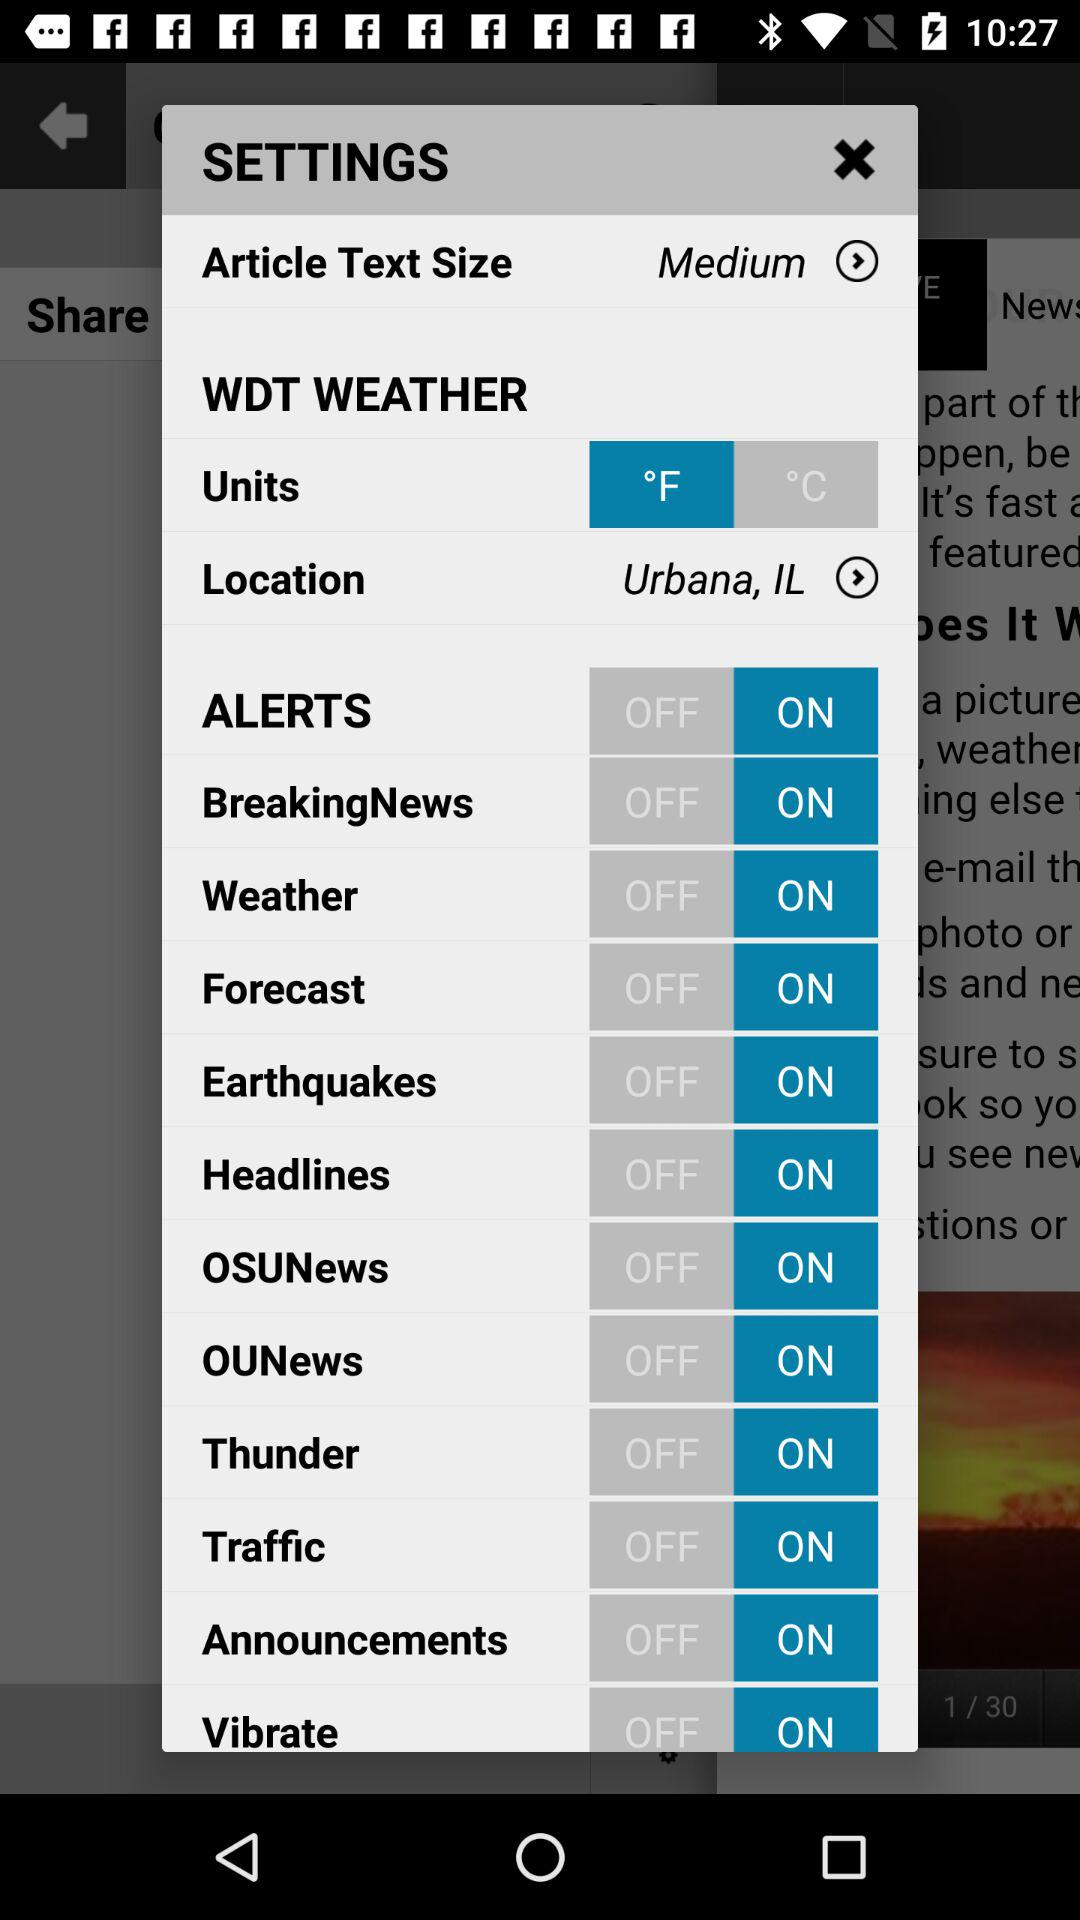What is the status of "Headlines"? The status is "on". 